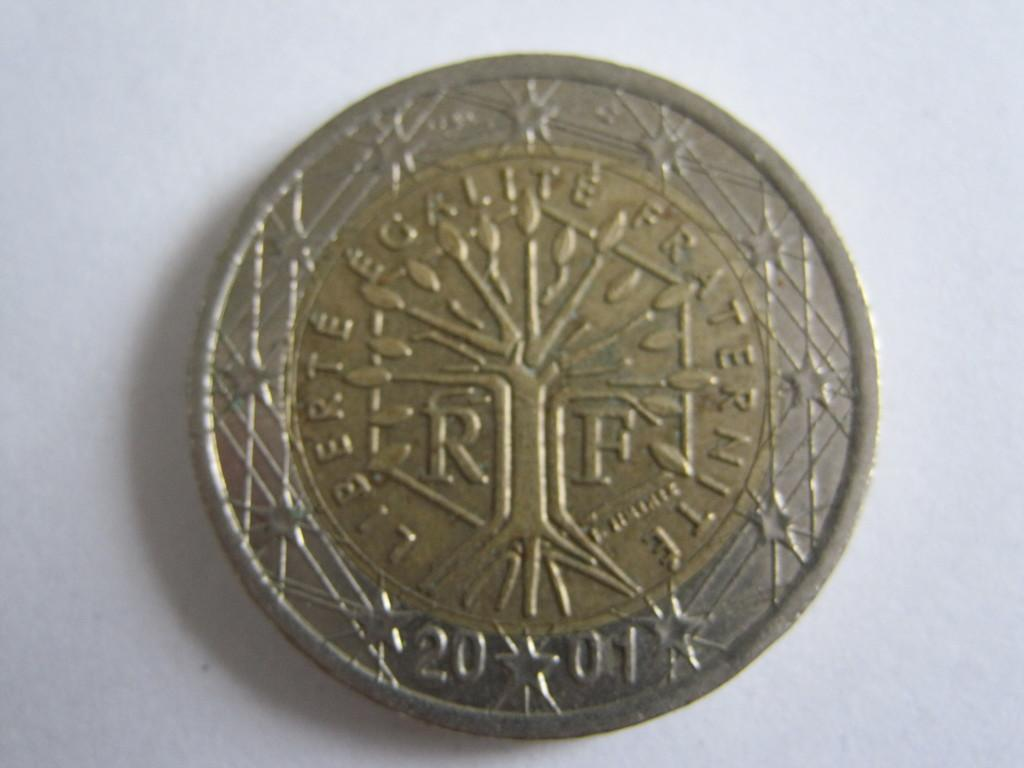What object is the main focus of the image? There is a coin in the image. What color is the background of the image? The background of the image is white. Can you tell me how many goats are present in the image? There are no goats present in the image; it only features a coin on a white background. What type of hook is used to hold the coin in the image? There is no hook present in the image; the coin is simply resting on the white background. 